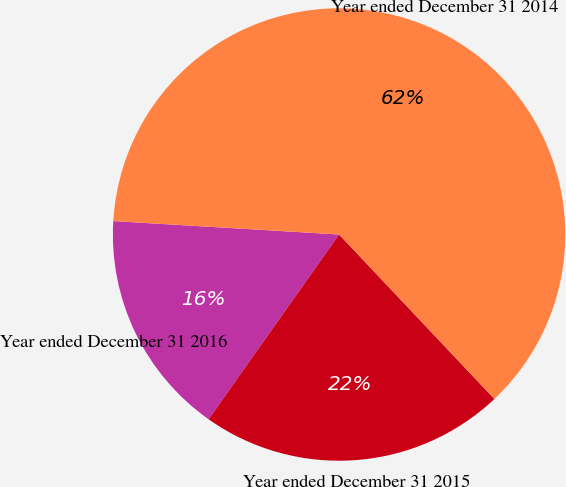<chart> <loc_0><loc_0><loc_500><loc_500><pie_chart><fcel>Year ended December 31 2016<fcel>Year ended December 31 2015<fcel>Year ended December 31 2014<nl><fcel>16.16%<fcel>21.83%<fcel>62.01%<nl></chart> 